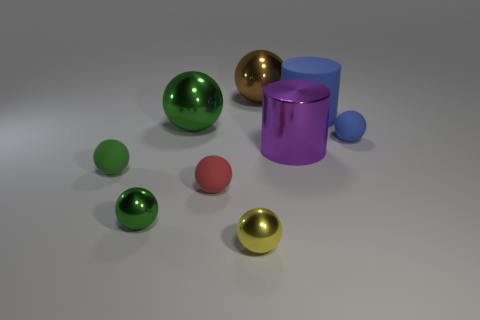How many green spheres must be subtracted to get 1 green spheres? 2 Subtract all blue cylinders. How many green spheres are left? 3 Subtract 4 balls. How many balls are left? 3 Subtract all red balls. How many balls are left? 6 Subtract all green matte spheres. How many spheres are left? 6 Subtract all yellow spheres. Subtract all cyan blocks. How many spheres are left? 6 Add 1 big brown metallic cylinders. How many objects exist? 10 Subtract all spheres. How many objects are left? 2 Subtract all large cylinders. Subtract all large things. How many objects are left? 3 Add 1 brown metal objects. How many brown metal objects are left? 2 